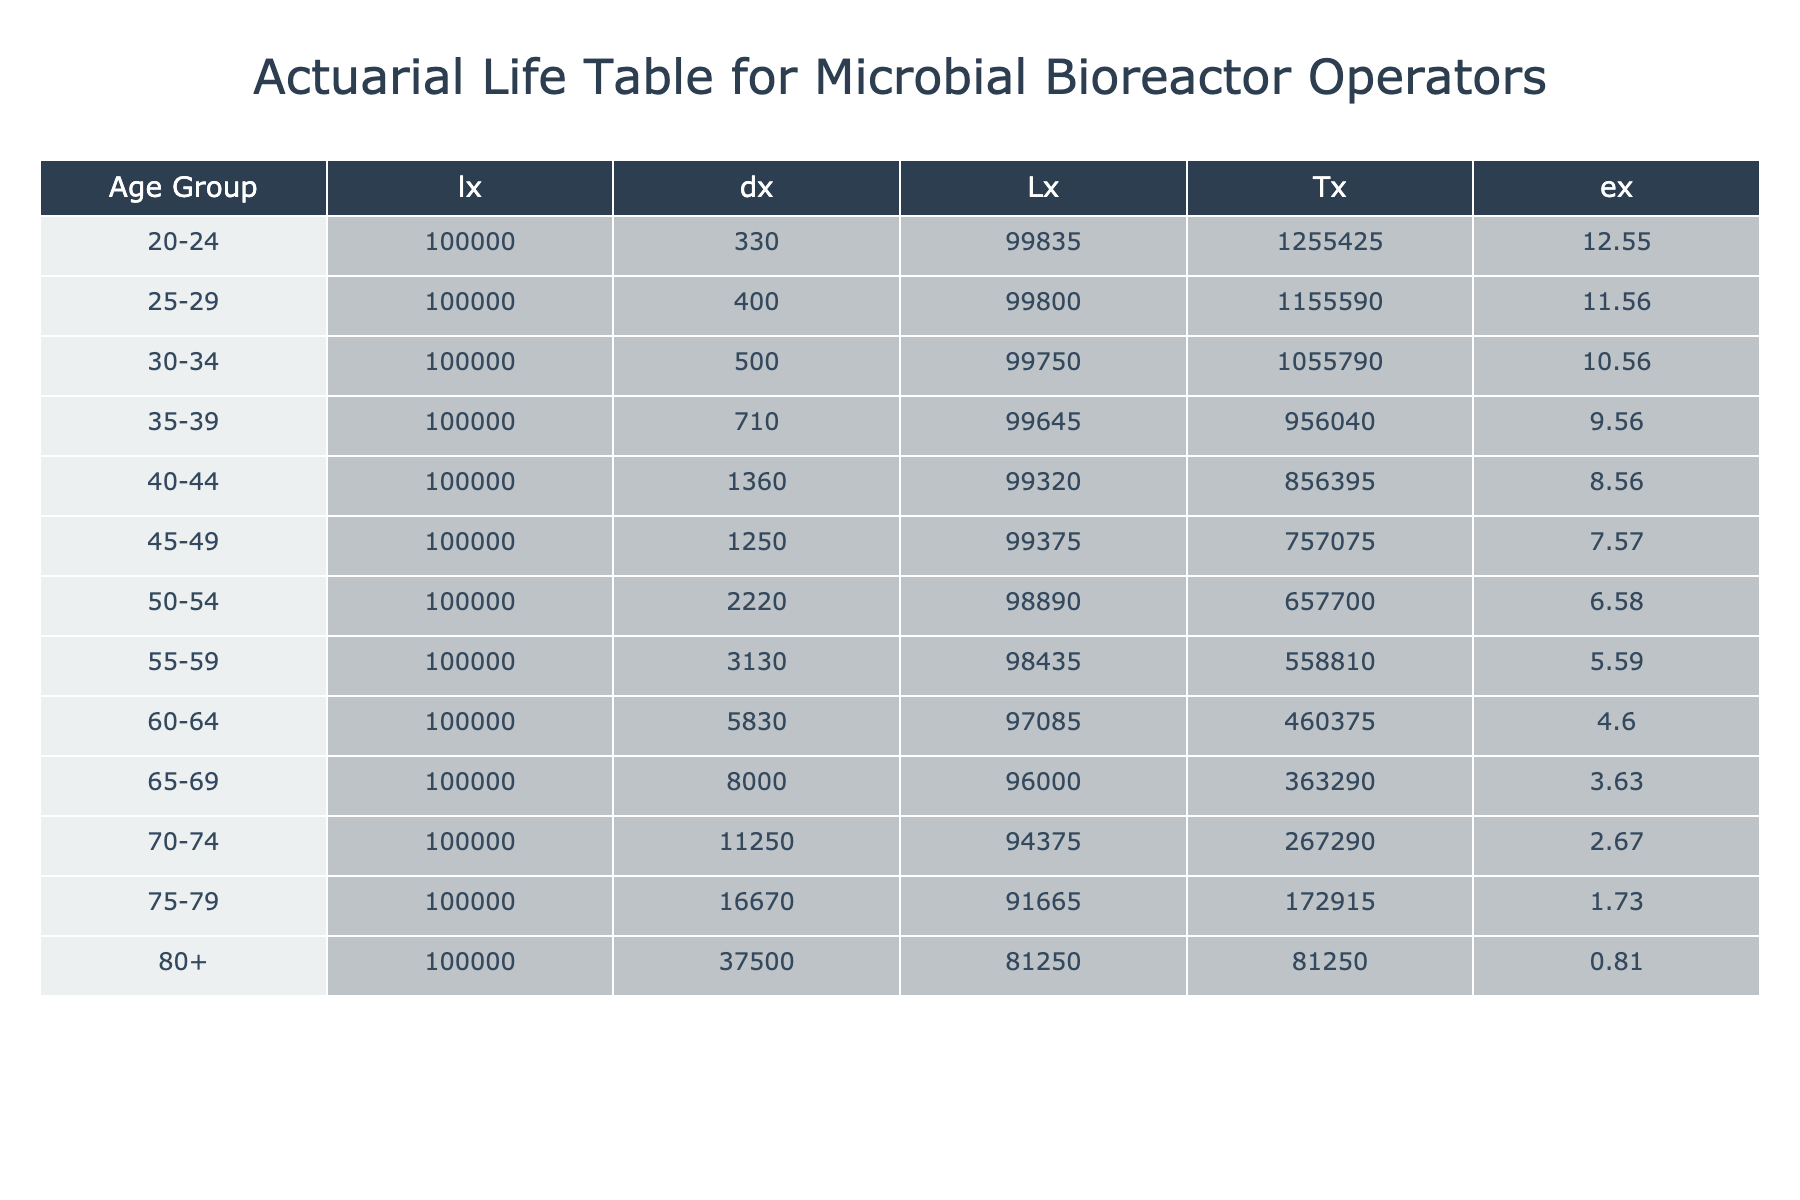What is the mortality rate for the age group 55-59? The mortality rate for the age group 55-59 is listed directly in the table under the "Mortality_Rate" column corresponding to the "55-59" age group. The value is 0.0313.
Answer: 0.0313 Which age group has the highest number of deaths? To find the highest number of deaths, we look at the "Deaths" column in the table. The highest value is 150 in the "80+" age group.
Answer: 150 What is the total number of deaths for operators aged 50 and above? We sum the "Deaths" for age groups 50-54 (40), 55-59 (50), 60-64 (70), 65-69 (80), 70-74 (90), 75-79 (100), and 80+ (150). The total is 40 + 50 + 70 + 80 + 90 + 100 + 150 = 580.
Answer: 580 What is the average mortality rate of the age groups from 25-29 to 65-69? To find the average, we take the mortality rates for the groups 25-29 (0.0040), 30-34 (0.0050), 35-39 (0.0071), 40-44 (0.0136), 45-49 (0.0125), 50-54 (0.0222), 55-59 (0.0313), and 60-64 (0.0583). The sum is 0.0040 + 0.0050 + 0.0071 + 0.0136 + 0.0125 + 0.0222 + 0.0313 + 0.0583 = 0.1530. There are 8 age groups, so the average is 0.1530 / 8 = 0.0191.
Answer: 0.0191 Is the mortality rate for the age group 35-39 greater than that of 40-44? The mortality rate for 35-39 is 0.0071 and for 40-44 is 0.0136. Since 0.0071 is less than 0.0136, the statement is false.
Answer: No What is the difference in the number of deaths between the age group 70-74 and 75-79? The number of deaths in the 70-74 age group is 90, and in the 75-79 age group, it is 100. The difference is 100 - 90 = 10.
Answer: 10 How many individuals are in the age group 40-44? The population for the age group 40-44 is directly given in the table under the "Population" column for this age group, which is 2200.
Answer: 2200 What age group has the lowest mortality rate, and what is that rate? The age group with the lowest mortality rate can be found by checking all the entries for the lowest value. The age group 20-24 has a mortality rate of 0.0033, which is the smallest.
Answer: 20-24, 0.0033 